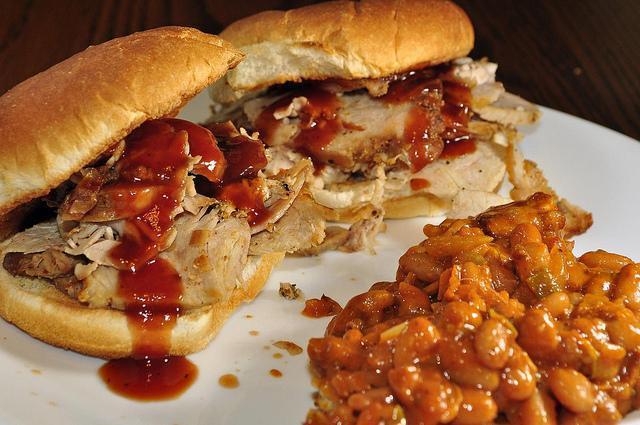What is the original color of the baked beans in the dish?
Answer the question by selecting the correct answer among the 4 following choices.
Options: Brown, gray, white, black. White. 